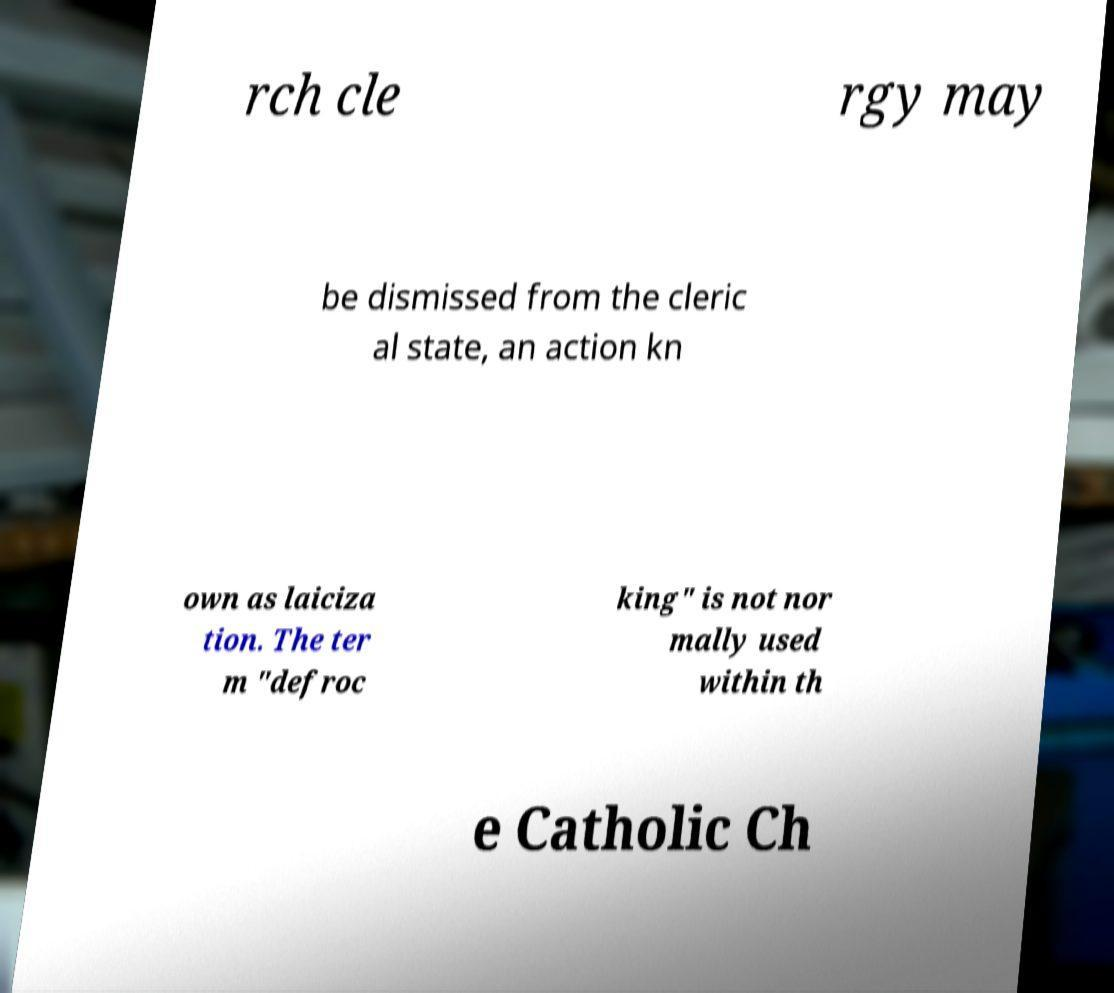What messages or text are displayed in this image? I need them in a readable, typed format. rch cle rgy may be dismissed from the cleric al state, an action kn own as laiciza tion. The ter m "defroc king" is not nor mally used within th e Catholic Ch 